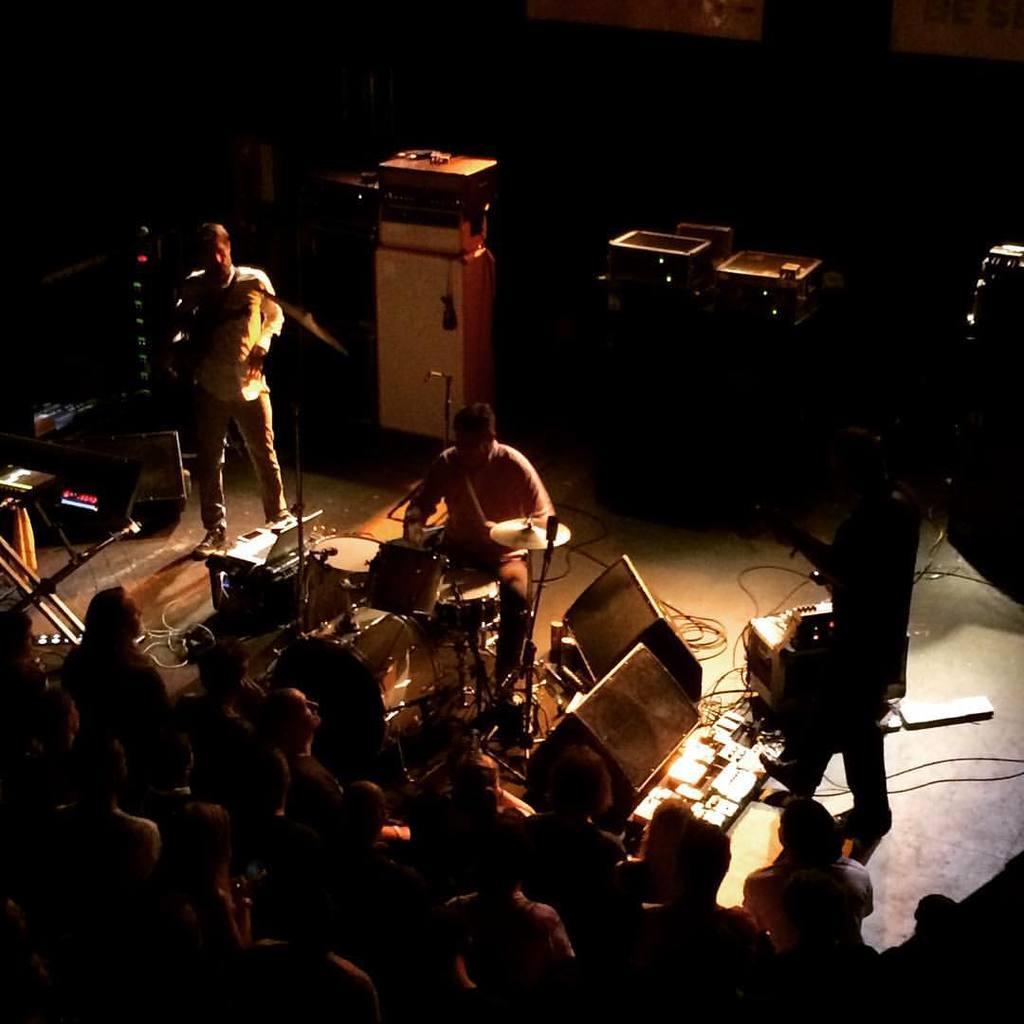Please provide a concise description of this image. In this image I see 3 persons on the stage and I see these 2 are holding musical instruments in their hands and there are lot of people over here. I can also see few equipment over here. 